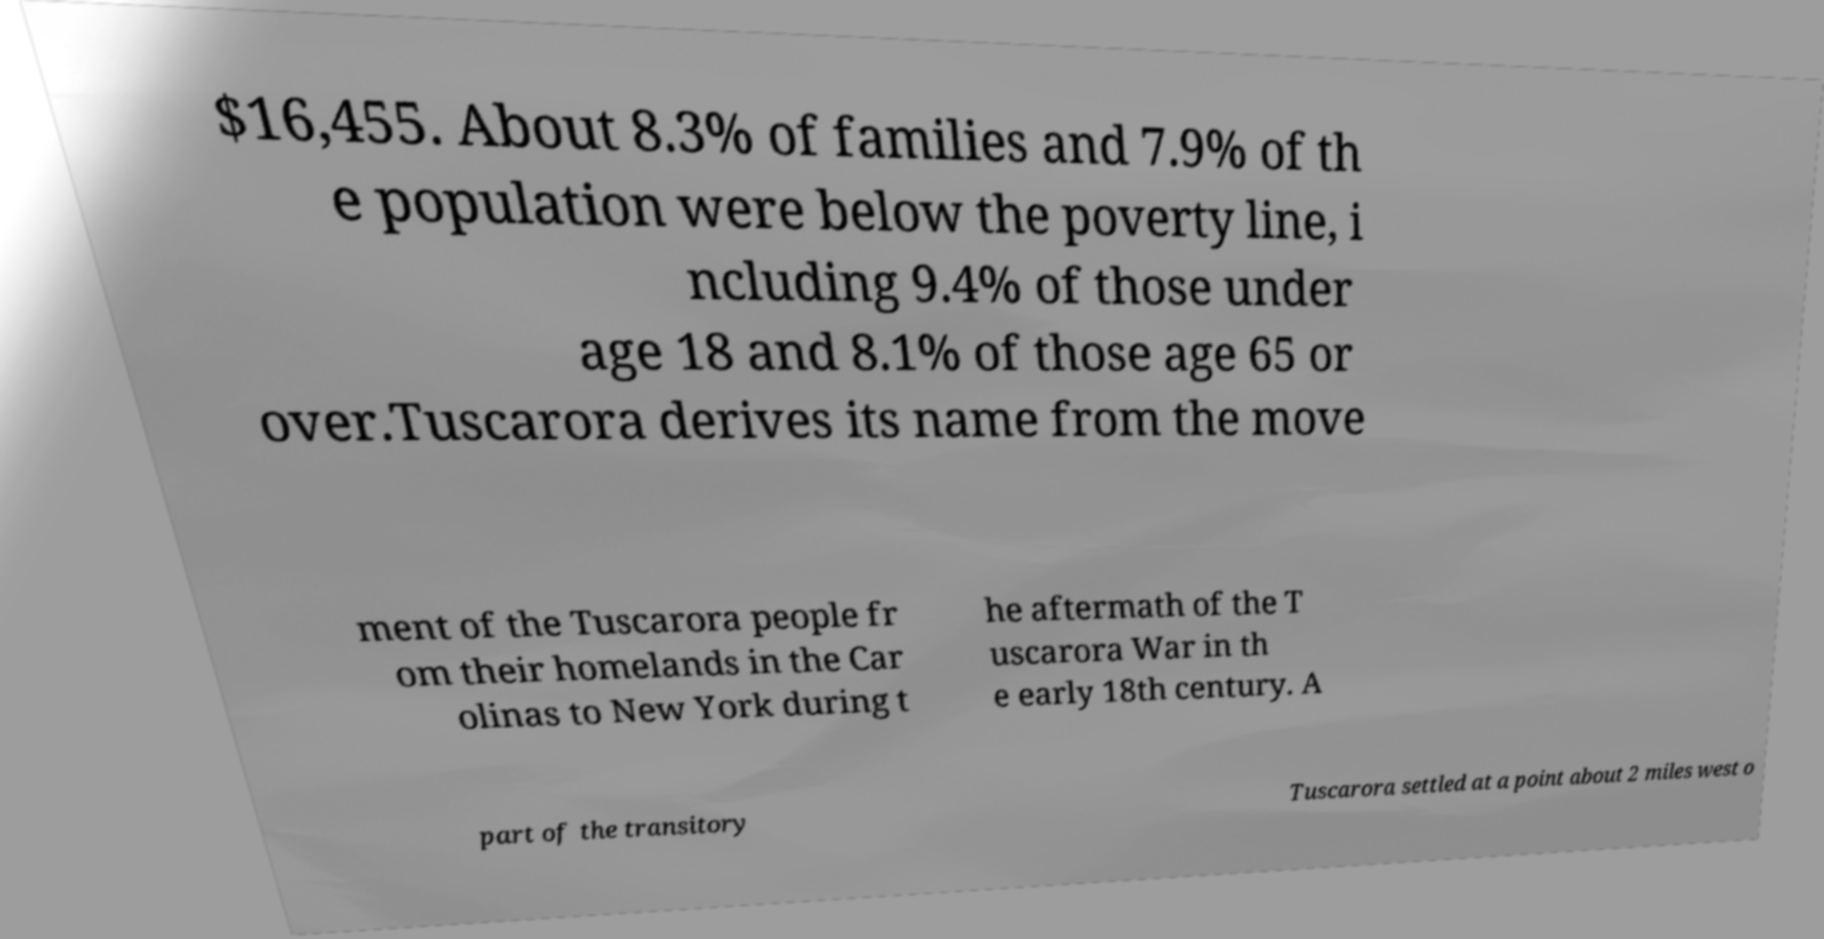Could you assist in decoding the text presented in this image and type it out clearly? $16,455. About 8.3% of families and 7.9% of th e population were below the poverty line, i ncluding 9.4% of those under age 18 and 8.1% of those age 65 or over.Tuscarora derives its name from the move ment of the Tuscarora people fr om their homelands in the Car olinas to New York during t he aftermath of the T uscarora War in th e early 18th century. A part of the transitory Tuscarora settled at a point about 2 miles west o 